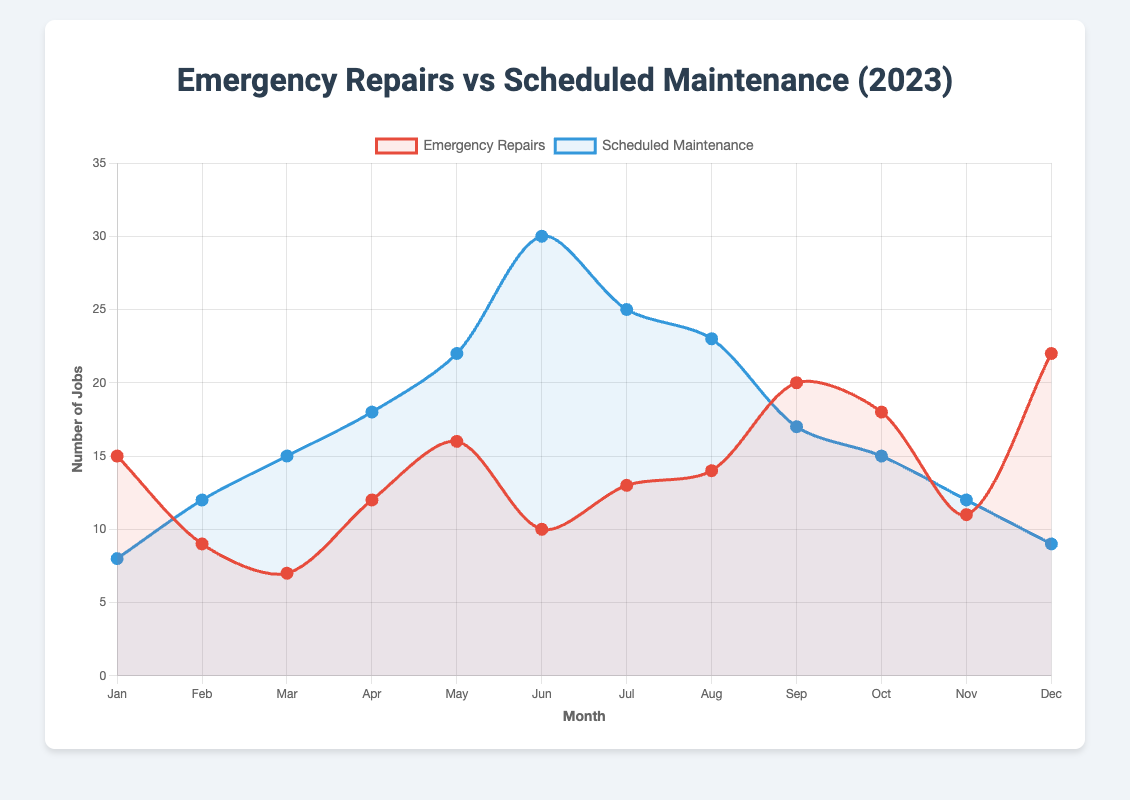Which month has the highest number of emergency repairs? December has the highest number of emergency repairs at 22, as indicated by the tallest point on the red-colored line in December.
Answer: December Which month has the highest number of scheduled maintenance jobs? June has the highest number of scheduled maintenance jobs at 30, as indicated by the tallest point on the blue-colored line in June.
Answer: June How many more emergency repairs were there in January compared to February? January had 15 emergency repairs, and February had 9. The difference is 15 - 9 = 6.
Answer: 6 In which month do scheduled maintenance jobs start to decrease significantly? Scheduled maintenance jobs start decreasing significantly after June. This can be observed from the continuous drop in the blue-colored line from June (30) to July (25).
Answer: June What is the average number of emergency repairs across all months? Sum of emergency repairs: 15 + 9 + 7 + 12 + 16 + 10 + 13 + 14 + 20 + 18 + 11 + 22 = 167. The average is 167 / 12 ≈ 13.92.
Answer: 13.92 How does the number of emergency repairs in October compare to November? October has 18 emergency repairs and November has 11. So, October has 7 more emergency repairs than November.
Answer: 7 more Which month sees an equal number of emergency repairs and scheduled maintenance jobs? There is no month where the number of emergency repairs equals the number of scheduled maintenance jobs.
Answer: None How many months have scheduled maintenance jobs higher than emergency repairs? The months where scheduled maintenance jobs exceed emergency repairs are February, March, April, May, June, July, and August. This accounts for 7 months.
Answer: 7 What is the trend of emergency repairs from August to September? The number of emergency repairs increases from 14 in August to 20 in September, indicating a rising trend.
Answer: Rising What is the combined total of scheduled maintenance jobs for the first three months of the year? Scheduled maintenance in January is 8, in February is 12, and in March is 15. The combined total is 8 + 12 + 15 = 35.
Answer: 35 